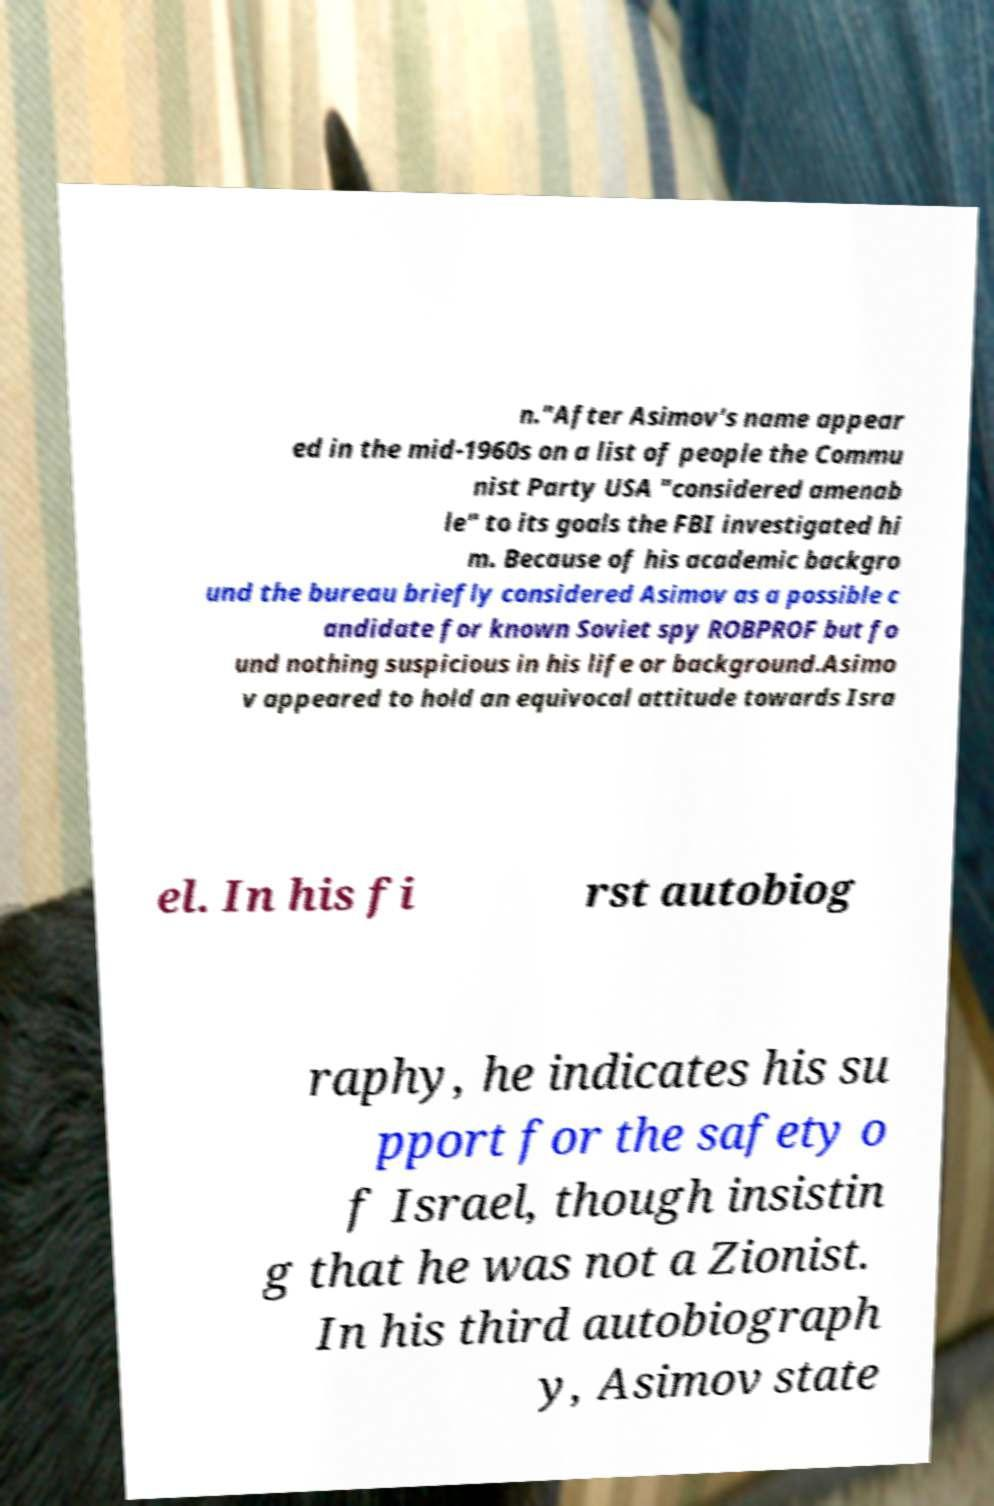Please identify and transcribe the text found in this image. n."After Asimov's name appear ed in the mid-1960s on a list of people the Commu nist Party USA "considered amenab le" to its goals the FBI investigated hi m. Because of his academic backgro und the bureau briefly considered Asimov as a possible c andidate for known Soviet spy ROBPROF but fo und nothing suspicious in his life or background.Asimo v appeared to hold an equivocal attitude towards Isra el. In his fi rst autobiog raphy, he indicates his su pport for the safety o f Israel, though insistin g that he was not a Zionist. In his third autobiograph y, Asimov state 